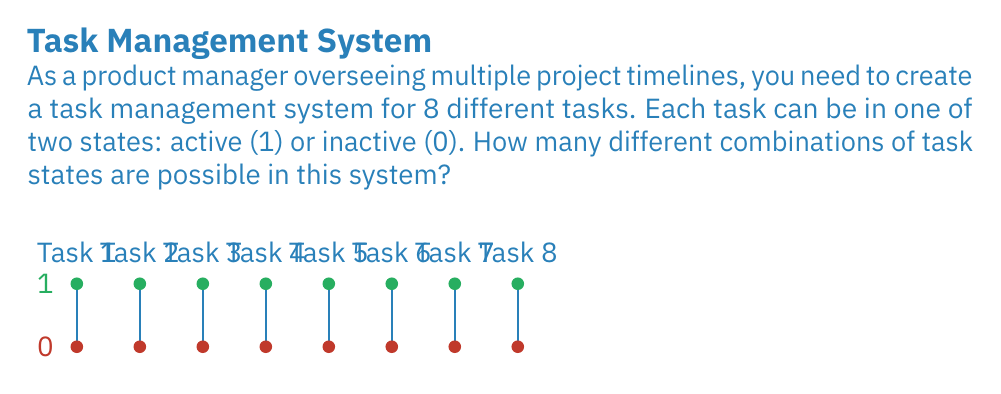What is the answer to this math problem? To solve this problem, we can use the principles of the binary number system and combinatorics:

1) Each task has 2 possible states (0 or 1), and there are 8 tasks in total.

2) This scenario can be represented as an 8-digit binary number, where each digit represents a task's state.

3) In a binary system with n digits, the number of possible combinations is given by the formula:

   $$\text{Number of combinations} = 2^n$$

4) In this case, n = 8 (because there are 8 tasks), so we calculate:

   $$\text{Number of combinations} = 2^8$$

5) Evaluating this:
   $$2^8 = 2 \times 2 \times 2 \times 2 \times 2 \times 2 \times 2 \times 2 = 256$$

Therefore, there are 256 possible combinations of task states in this system.
Answer: $2^8 = 256$ combinations 